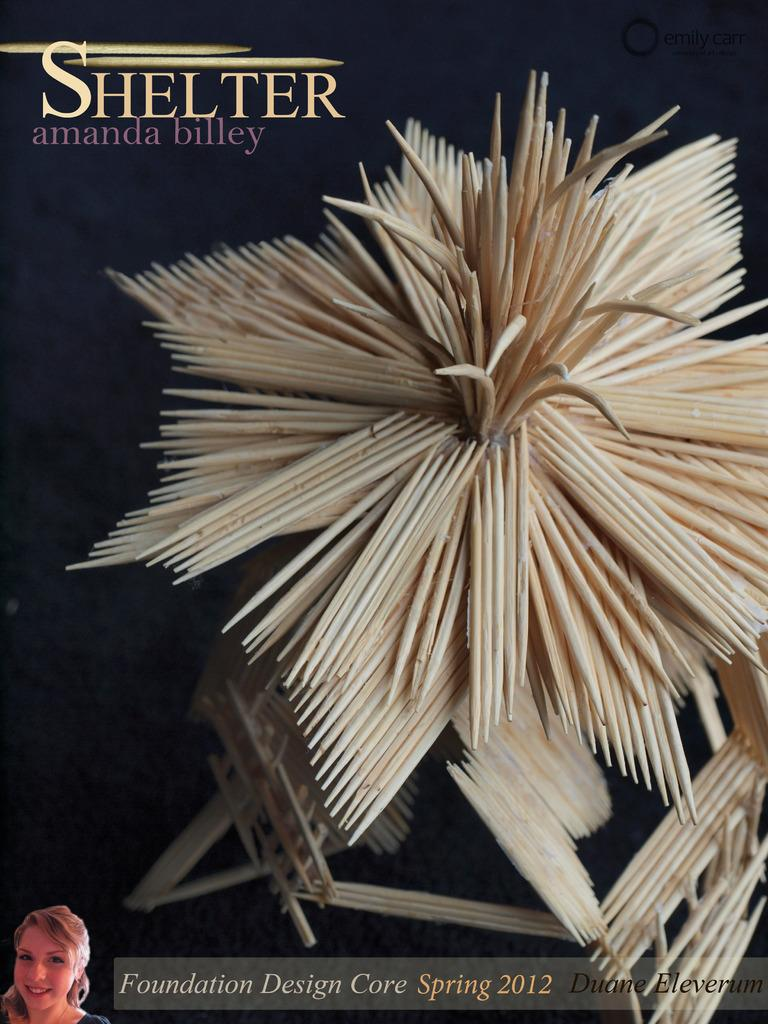What is present in the image that contains both images and text? There is a poster in the image that contains images and text. How many waves can be seen on the poster in the image? There are no waves present on the poster in the image. What type of growth is depicted on the poster in the image? There is no growth depicted on the poster in the image. 